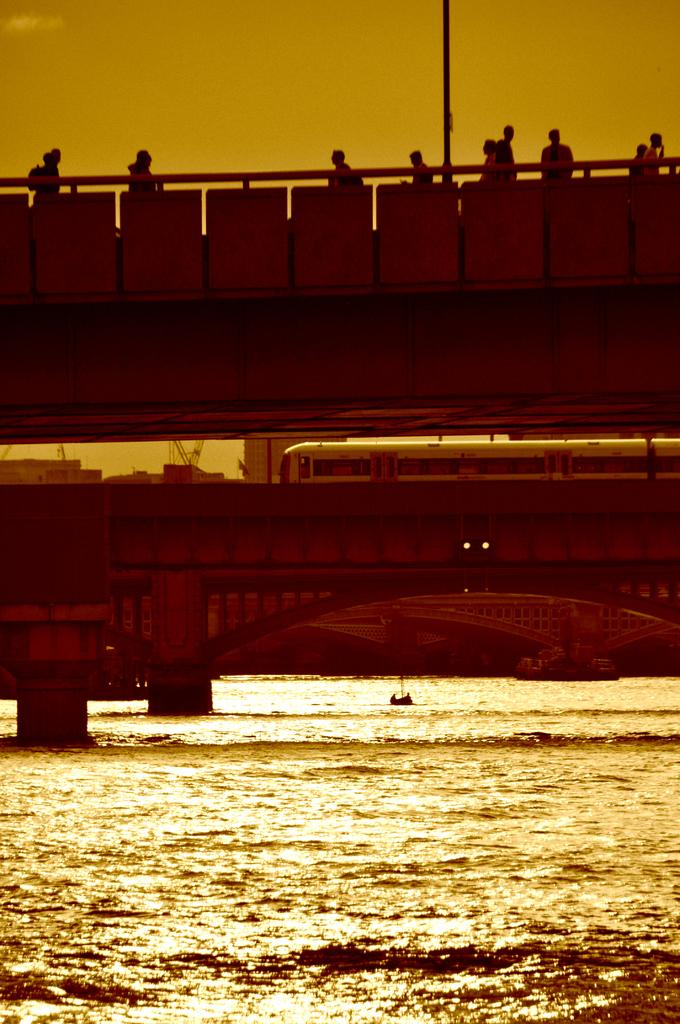What is at the bottom of the image? There is a surface of water at the bottom of the image. What structure can be seen in the image? There is a bridge in the image. What mode of transportation is present in the image? There is a train in the image. Who or what can be seen in the image? There are persons in the image. What can be seen in the distance in the image? The sky is visible in the background of the image. What is the taste of the science in the image? There is no science present in the image, and therefore no taste can be associated with it. 